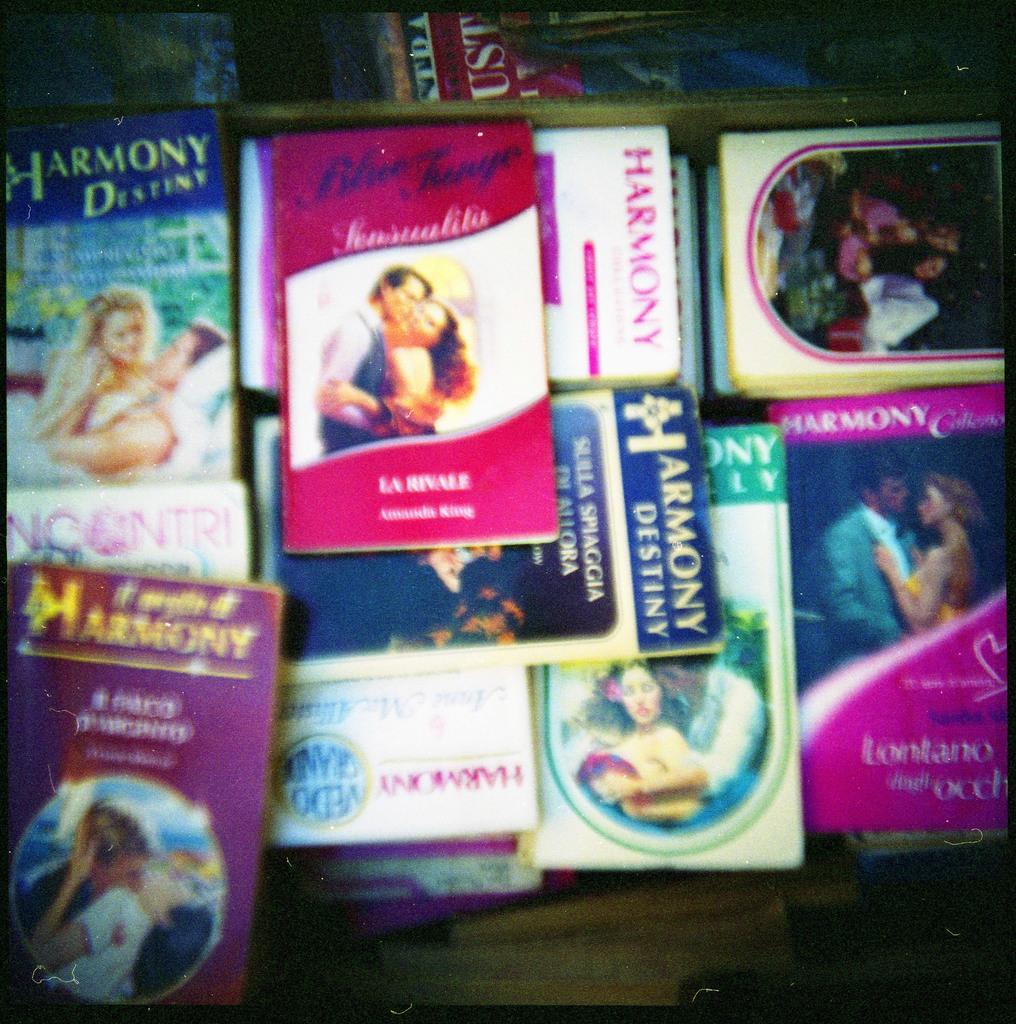Please provide a concise description of this image. In this image, we can see so many books are placed on the surface. 